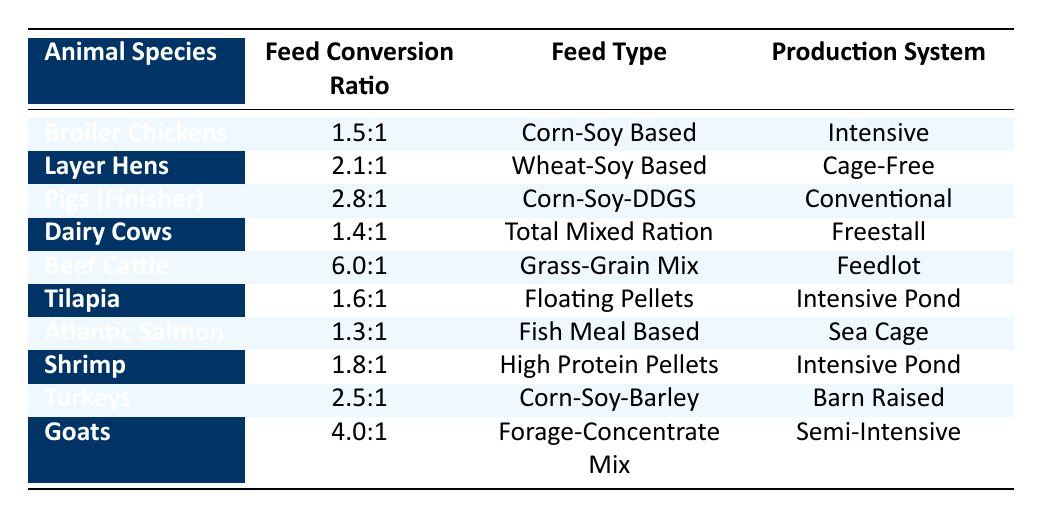What is the Feed Conversion Ratio for Dairy Cows? The table shows that Dairy Cows have a Feed Conversion Ratio of 1.4:1.
Answer: 1.4:1 Which animal species has the highest Feed Conversion Ratio? Examining the table, Beef Cattle has the highest Feed Conversion Ratio at 6.0:1.
Answer: Beef Cattle What type of feed do Layer Hens consume? The table indicates that Layer Hens are fed a Wheat-Soy Based feed.
Answer: Wheat-Soy Based Is the Feed Conversion Ratio for Atlantic Salmon lower than that for Tilapia? By comparing the values, Atlantic Salmon has a Feed Conversion Ratio of 1.3:1, which is lower than Tilapia's 1.6:1, therefore the statement is true.
Answer: Yes What is the average Feed Conversion Ratio for pigs? The table lists only one value for pigs, which is 2.8:1, so the average also remains 2.8:1.
Answer: 2.8:1 How many animal species have a Feed Conversion Ratio of less than 2.0:1? Analyzing the table, Dairy Cows (1.4:1), Atlantic Salmon (1.3:1), and Broiler Chickens (1.5:1) all have ratios less than 2.0:1. This gives us a total of 3 species.
Answer: 3 Which production system is associated with the lowest Feed Conversion Ratio? The lowest Feed Conversion Ratio (1.3:1) is found for Atlantic Salmon, which uses a Sea Cage production system.
Answer: Sea Cage Is there any shrimp feed type listed in the table? Yes, the table shows that shrimp are fed High Protein Pellets.
Answer: Yes What is the difference in Feed Conversion Ratios between Goats and Turkeys? The Goats have a Feed Conversion Ratio of 4.0:1 and Turkeys have a ratio of 2.5:1. The difference is calculated as 4.0 - 2.5 = 1.5.
Answer: 1.5 